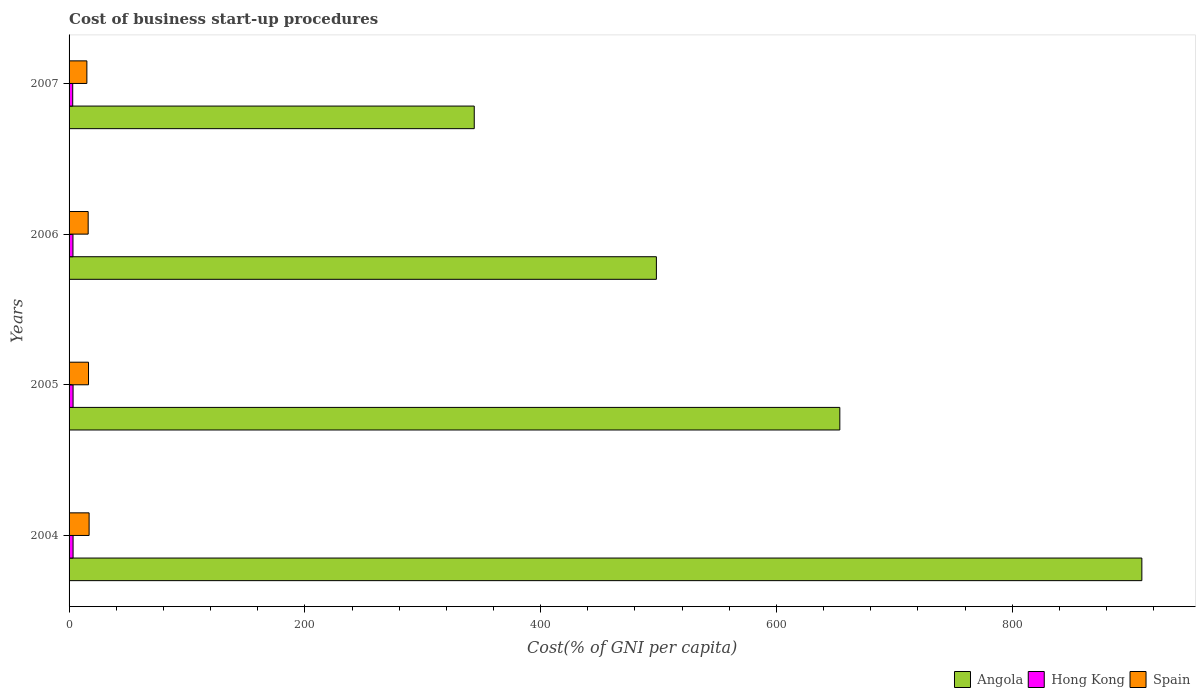How many different coloured bars are there?
Give a very brief answer. 3. Are the number of bars per tick equal to the number of legend labels?
Your answer should be very brief. Yes. How many bars are there on the 3rd tick from the top?
Your answer should be compact. 3. How many bars are there on the 3rd tick from the bottom?
Your answer should be compact. 3. What is the label of the 4th group of bars from the top?
Provide a short and direct response. 2004. Across all years, what is the maximum cost of business start-up procedures in Angola?
Make the answer very short. 910. Across all years, what is the minimum cost of business start-up procedures in Hong Kong?
Make the answer very short. 3.1. In which year was the cost of business start-up procedures in Angola minimum?
Keep it short and to the point. 2007. What is the difference between the cost of business start-up procedures in Hong Kong in 2004 and that in 2006?
Offer a very short reply. 0.1. What is the difference between the cost of business start-up procedures in Angola in 2006 and the cost of business start-up procedures in Spain in 2007?
Offer a very short reply. 483.1. In the year 2004, what is the difference between the cost of business start-up procedures in Spain and cost of business start-up procedures in Angola?
Give a very brief answer. -893. What is the ratio of the cost of business start-up procedures in Spain in 2004 to that in 2007?
Offer a terse response. 1.13. Is the difference between the cost of business start-up procedures in Spain in 2004 and 2006 greater than the difference between the cost of business start-up procedures in Angola in 2004 and 2006?
Give a very brief answer. No. What is the difference between the highest and the second highest cost of business start-up procedures in Angola?
Provide a succinct answer. 256.2. What is the difference between the highest and the lowest cost of business start-up procedures in Spain?
Ensure brevity in your answer.  1.9. In how many years, is the cost of business start-up procedures in Spain greater than the average cost of business start-up procedures in Spain taken over all years?
Provide a short and direct response. 2. Is the sum of the cost of business start-up procedures in Spain in 2005 and 2006 greater than the maximum cost of business start-up procedures in Hong Kong across all years?
Give a very brief answer. Yes. What does the 1st bar from the top in 2005 represents?
Provide a succinct answer. Spain. What does the 2nd bar from the bottom in 2004 represents?
Your answer should be very brief. Hong Kong. Are all the bars in the graph horizontal?
Make the answer very short. Yes. How many years are there in the graph?
Your answer should be compact. 4. What is the difference between two consecutive major ticks on the X-axis?
Provide a succinct answer. 200. Are the values on the major ticks of X-axis written in scientific E-notation?
Give a very brief answer. No. How many legend labels are there?
Ensure brevity in your answer.  3. What is the title of the graph?
Give a very brief answer. Cost of business start-up procedures. What is the label or title of the X-axis?
Offer a terse response. Cost(% of GNI per capita). What is the Cost(% of GNI per capita) in Angola in 2004?
Provide a succinct answer. 910. What is the Cost(% of GNI per capita) in Angola in 2005?
Your answer should be compact. 653.8. What is the Cost(% of GNI per capita) of Hong Kong in 2005?
Provide a succinct answer. 3.4. What is the Cost(% of GNI per capita) in Spain in 2005?
Provide a succinct answer. 16.5. What is the Cost(% of GNI per capita) of Angola in 2006?
Your answer should be very brief. 498.2. What is the Cost(% of GNI per capita) in Hong Kong in 2006?
Offer a terse response. 3.3. What is the Cost(% of GNI per capita) of Angola in 2007?
Give a very brief answer. 343.7. What is the Cost(% of GNI per capita) in Hong Kong in 2007?
Your answer should be very brief. 3.1. What is the Cost(% of GNI per capita) of Spain in 2007?
Make the answer very short. 15.1. Across all years, what is the maximum Cost(% of GNI per capita) of Angola?
Ensure brevity in your answer.  910. Across all years, what is the maximum Cost(% of GNI per capita) in Hong Kong?
Give a very brief answer. 3.4. Across all years, what is the minimum Cost(% of GNI per capita) of Angola?
Provide a succinct answer. 343.7. Across all years, what is the minimum Cost(% of GNI per capita) of Spain?
Make the answer very short. 15.1. What is the total Cost(% of GNI per capita) in Angola in the graph?
Your answer should be very brief. 2405.7. What is the total Cost(% of GNI per capita) of Spain in the graph?
Offer a very short reply. 64.8. What is the difference between the Cost(% of GNI per capita) in Angola in 2004 and that in 2005?
Offer a very short reply. 256.2. What is the difference between the Cost(% of GNI per capita) in Angola in 2004 and that in 2006?
Your answer should be compact. 411.8. What is the difference between the Cost(% of GNI per capita) of Hong Kong in 2004 and that in 2006?
Offer a terse response. 0.1. What is the difference between the Cost(% of GNI per capita) of Spain in 2004 and that in 2006?
Your response must be concise. 0.8. What is the difference between the Cost(% of GNI per capita) in Angola in 2004 and that in 2007?
Your answer should be compact. 566.3. What is the difference between the Cost(% of GNI per capita) of Angola in 2005 and that in 2006?
Provide a succinct answer. 155.6. What is the difference between the Cost(% of GNI per capita) in Hong Kong in 2005 and that in 2006?
Offer a terse response. 0.1. What is the difference between the Cost(% of GNI per capita) in Angola in 2005 and that in 2007?
Give a very brief answer. 310.1. What is the difference between the Cost(% of GNI per capita) in Angola in 2006 and that in 2007?
Keep it short and to the point. 154.5. What is the difference between the Cost(% of GNI per capita) of Angola in 2004 and the Cost(% of GNI per capita) of Hong Kong in 2005?
Offer a terse response. 906.6. What is the difference between the Cost(% of GNI per capita) in Angola in 2004 and the Cost(% of GNI per capita) in Spain in 2005?
Provide a succinct answer. 893.5. What is the difference between the Cost(% of GNI per capita) of Angola in 2004 and the Cost(% of GNI per capita) of Hong Kong in 2006?
Ensure brevity in your answer.  906.7. What is the difference between the Cost(% of GNI per capita) in Angola in 2004 and the Cost(% of GNI per capita) in Spain in 2006?
Offer a very short reply. 893.8. What is the difference between the Cost(% of GNI per capita) in Hong Kong in 2004 and the Cost(% of GNI per capita) in Spain in 2006?
Make the answer very short. -12.8. What is the difference between the Cost(% of GNI per capita) in Angola in 2004 and the Cost(% of GNI per capita) in Hong Kong in 2007?
Give a very brief answer. 906.9. What is the difference between the Cost(% of GNI per capita) of Angola in 2004 and the Cost(% of GNI per capita) of Spain in 2007?
Ensure brevity in your answer.  894.9. What is the difference between the Cost(% of GNI per capita) in Hong Kong in 2004 and the Cost(% of GNI per capita) in Spain in 2007?
Offer a terse response. -11.7. What is the difference between the Cost(% of GNI per capita) of Angola in 2005 and the Cost(% of GNI per capita) of Hong Kong in 2006?
Keep it short and to the point. 650.5. What is the difference between the Cost(% of GNI per capita) of Angola in 2005 and the Cost(% of GNI per capita) of Spain in 2006?
Your answer should be compact. 637.6. What is the difference between the Cost(% of GNI per capita) of Angola in 2005 and the Cost(% of GNI per capita) of Hong Kong in 2007?
Offer a terse response. 650.7. What is the difference between the Cost(% of GNI per capita) of Angola in 2005 and the Cost(% of GNI per capita) of Spain in 2007?
Keep it short and to the point. 638.7. What is the difference between the Cost(% of GNI per capita) of Angola in 2006 and the Cost(% of GNI per capita) of Hong Kong in 2007?
Provide a short and direct response. 495.1. What is the difference between the Cost(% of GNI per capita) of Angola in 2006 and the Cost(% of GNI per capita) of Spain in 2007?
Provide a succinct answer. 483.1. What is the average Cost(% of GNI per capita) in Angola per year?
Your response must be concise. 601.42. In the year 2004, what is the difference between the Cost(% of GNI per capita) in Angola and Cost(% of GNI per capita) in Hong Kong?
Keep it short and to the point. 906.6. In the year 2004, what is the difference between the Cost(% of GNI per capita) in Angola and Cost(% of GNI per capita) in Spain?
Your answer should be very brief. 893. In the year 2004, what is the difference between the Cost(% of GNI per capita) in Hong Kong and Cost(% of GNI per capita) in Spain?
Your answer should be very brief. -13.6. In the year 2005, what is the difference between the Cost(% of GNI per capita) of Angola and Cost(% of GNI per capita) of Hong Kong?
Make the answer very short. 650.4. In the year 2005, what is the difference between the Cost(% of GNI per capita) in Angola and Cost(% of GNI per capita) in Spain?
Keep it short and to the point. 637.3. In the year 2006, what is the difference between the Cost(% of GNI per capita) of Angola and Cost(% of GNI per capita) of Hong Kong?
Ensure brevity in your answer.  494.9. In the year 2006, what is the difference between the Cost(% of GNI per capita) in Angola and Cost(% of GNI per capita) in Spain?
Offer a terse response. 482. In the year 2006, what is the difference between the Cost(% of GNI per capita) of Hong Kong and Cost(% of GNI per capita) of Spain?
Your answer should be very brief. -12.9. In the year 2007, what is the difference between the Cost(% of GNI per capita) in Angola and Cost(% of GNI per capita) in Hong Kong?
Offer a terse response. 340.6. In the year 2007, what is the difference between the Cost(% of GNI per capita) of Angola and Cost(% of GNI per capita) of Spain?
Offer a terse response. 328.6. What is the ratio of the Cost(% of GNI per capita) of Angola in 2004 to that in 2005?
Provide a short and direct response. 1.39. What is the ratio of the Cost(% of GNI per capita) in Hong Kong in 2004 to that in 2005?
Provide a short and direct response. 1. What is the ratio of the Cost(% of GNI per capita) of Spain in 2004 to that in 2005?
Provide a succinct answer. 1.03. What is the ratio of the Cost(% of GNI per capita) of Angola in 2004 to that in 2006?
Keep it short and to the point. 1.83. What is the ratio of the Cost(% of GNI per capita) of Hong Kong in 2004 to that in 2006?
Keep it short and to the point. 1.03. What is the ratio of the Cost(% of GNI per capita) of Spain in 2004 to that in 2006?
Give a very brief answer. 1.05. What is the ratio of the Cost(% of GNI per capita) of Angola in 2004 to that in 2007?
Keep it short and to the point. 2.65. What is the ratio of the Cost(% of GNI per capita) of Hong Kong in 2004 to that in 2007?
Offer a terse response. 1.1. What is the ratio of the Cost(% of GNI per capita) in Spain in 2004 to that in 2007?
Your response must be concise. 1.13. What is the ratio of the Cost(% of GNI per capita) of Angola in 2005 to that in 2006?
Your response must be concise. 1.31. What is the ratio of the Cost(% of GNI per capita) of Hong Kong in 2005 to that in 2006?
Your answer should be compact. 1.03. What is the ratio of the Cost(% of GNI per capita) in Spain in 2005 to that in 2006?
Your answer should be compact. 1.02. What is the ratio of the Cost(% of GNI per capita) in Angola in 2005 to that in 2007?
Your answer should be very brief. 1.9. What is the ratio of the Cost(% of GNI per capita) of Hong Kong in 2005 to that in 2007?
Your answer should be very brief. 1.1. What is the ratio of the Cost(% of GNI per capita) of Spain in 2005 to that in 2007?
Ensure brevity in your answer.  1.09. What is the ratio of the Cost(% of GNI per capita) in Angola in 2006 to that in 2007?
Your response must be concise. 1.45. What is the ratio of the Cost(% of GNI per capita) in Hong Kong in 2006 to that in 2007?
Provide a succinct answer. 1.06. What is the ratio of the Cost(% of GNI per capita) of Spain in 2006 to that in 2007?
Ensure brevity in your answer.  1.07. What is the difference between the highest and the second highest Cost(% of GNI per capita) in Angola?
Offer a very short reply. 256.2. What is the difference between the highest and the second highest Cost(% of GNI per capita) in Hong Kong?
Your response must be concise. 0. What is the difference between the highest and the second highest Cost(% of GNI per capita) in Spain?
Your answer should be compact. 0.5. What is the difference between the highest and the lowest Cost(% of GNI per capita) in Angola?
Provide a short and direct response. 566.3. What is the difference between the highest and the lowest Cost(% of GNI per capita) in Spain?
Make the answer very short. 1.9. 